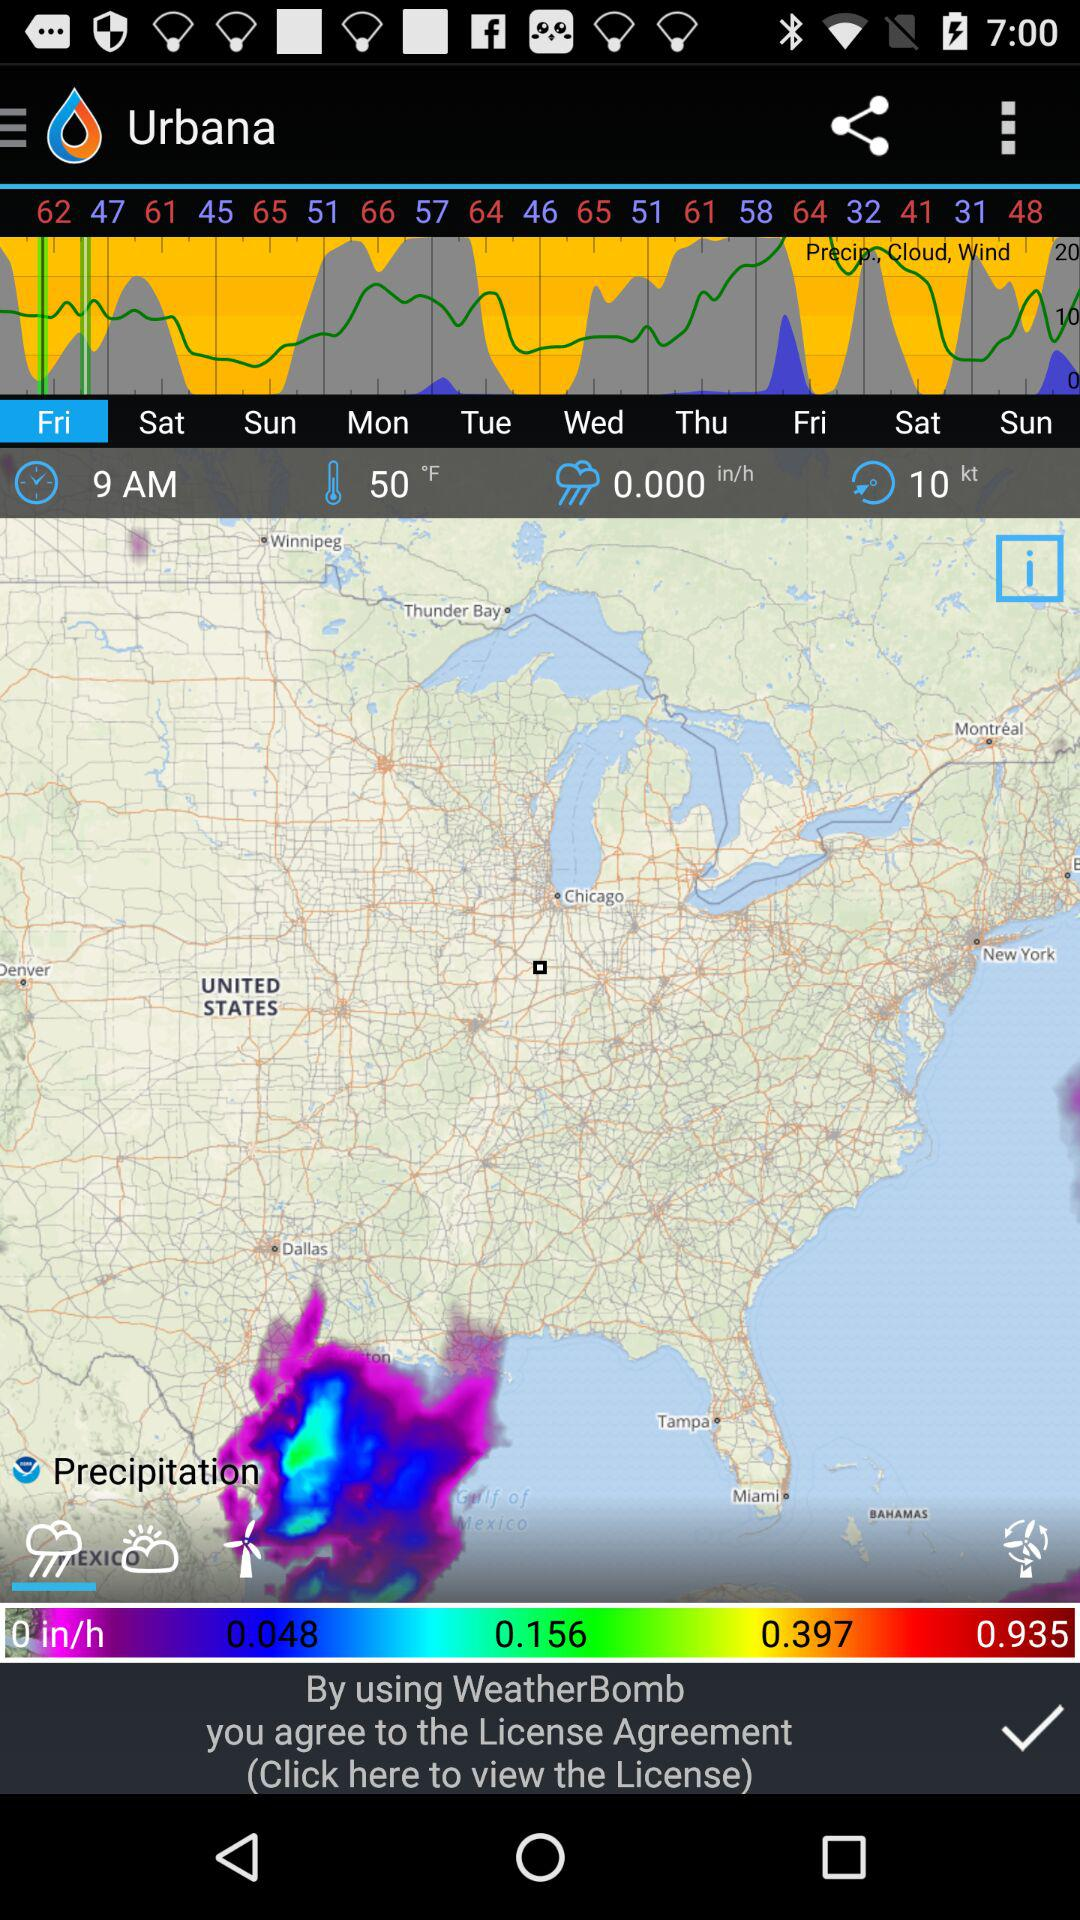What is the wind speed?
Answer the question using a single word or phrase. 10 kt 